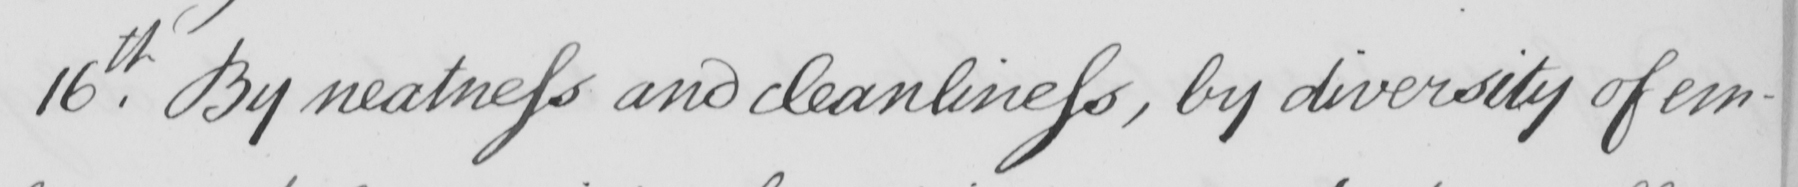What text is written in this handwritten line? 16.th By neatness and cleanliness , by diversity of em- 